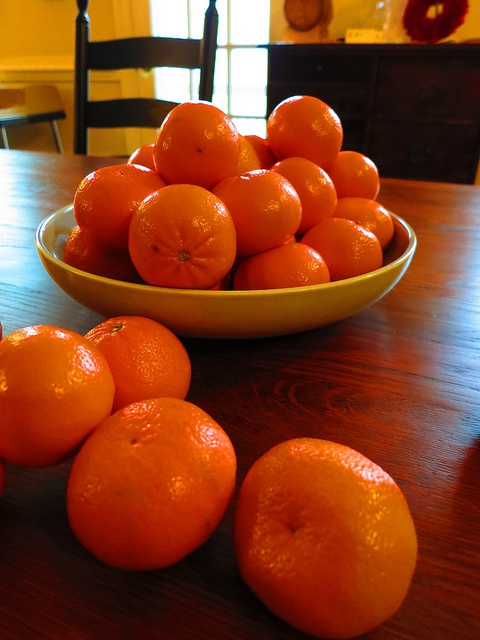Describe the objects in this image and their specific colors. I can see dining table in orange, brown, maroon, black, and red tones, orange in orange, brown, red, and maroon tones, orange in orange, maroon, and red tones, orange in orange, brown, red, and maroon tones, and bowl in orange, maroon, brown, and black tones in this image. 